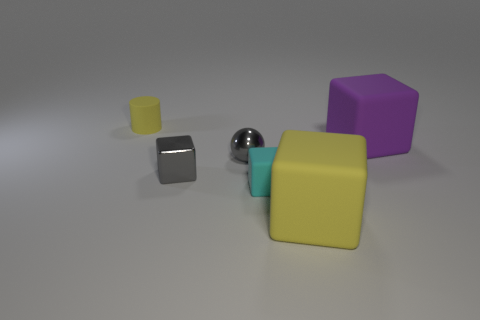How many objects are there in total, and can you describe their shapes? There are five objects in the image. Starting from the left, there's a small yellow cube, a medium-sized black cube, a shiny sphere in the center, a large yellow cube, and finally, a purple cube of medium size. 